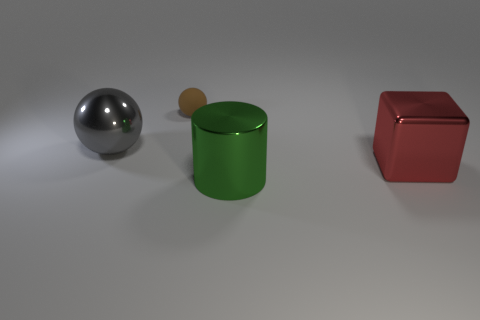Subtract all blue blocks. Subtract all brown balls. How many blocks are left? 1 Add 2 large shiny objects. How many objects exist? 6 Subtract all cylinders. How many objects are left? 3 Add 3 brown things. How many brown things are left? 4 Add 4 big gray cubes. How many big gray cubes exist? 4 Subtract 0 cyan balls. How many objects are left? 4 Subtract all brown shiny cubes. Subtract all big gray metal balls. How many objects are left? 3 